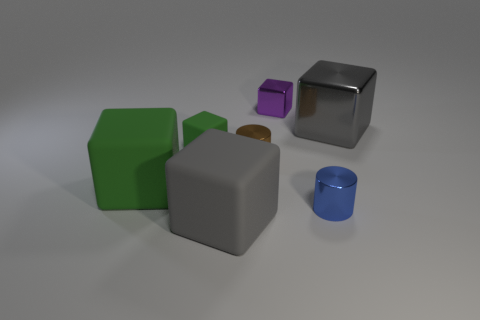There is a big cube that is both on the right side of the small green block and in front of the large metallic block; what is its color?
Ensure brevity in your answer.  Gray. The blue cylinder is what size?
Ensure brevity in your answer.  Small. How many yellow matte things are the same size as the purple shiny block?
Your response must be concise. 0. Do the large gray object in front of the gray shiny thing and the big gray block that is behind the gray rubber thing have the same material?
Provide a short and direct response. No. What is the small block in front of the cube that is right of the small purple metal cube made of?
Provide a succinct answer. Rubber. There is a large gray object that is to the left of the purple block; what material is it?
Your answer should be very brief. Rubber. What number of purple things have the same shape as the small green thing?
Offer a terse response. 1. What material is the big gray cube in front of the gray cube behind the gray object that is to the left of the gray metal cube made of?
Ensure brevity in your answer.  Rubber. Are there any big objects behind the big gray matte block?
Provide a short and direct response. Yes. What shape is the rubber thing that is the same size as the blue shiny object?
Provide a succinct answer. Cube. 